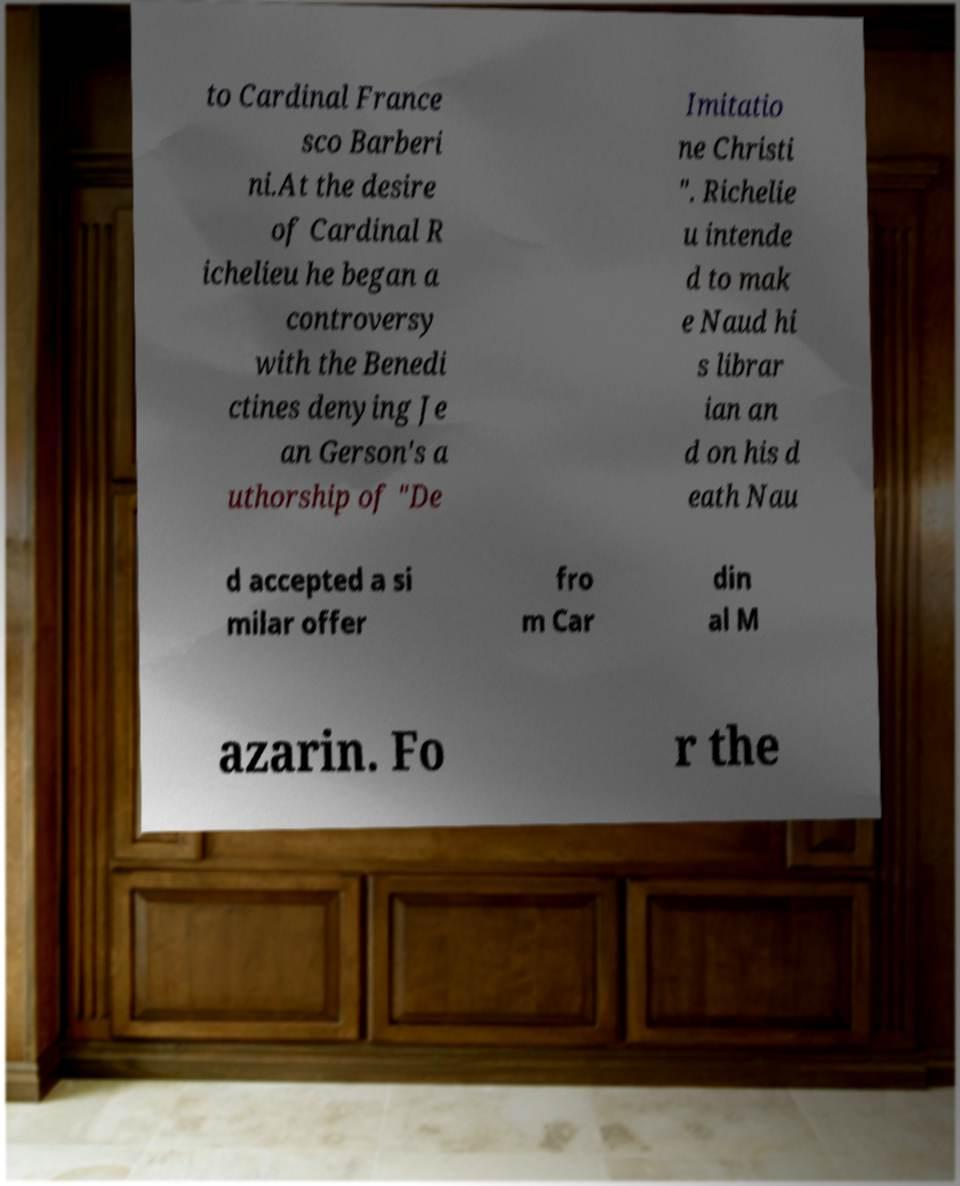What messages or text are displayed in this image? I need them in a readable, typed format. to Cardinal France sco Barberi ni.At the desire of Cardinal R ichelieu he began a controversy with the Benedi ctines denying Je an Gerson's a uthorship of "De Imitatio ne Christi ". Richelie u intende d to mak e Naud hi s librar ian an d on his d eath Nau d accepted a si milar offer fro m Car din al M azarin. Fo r the 